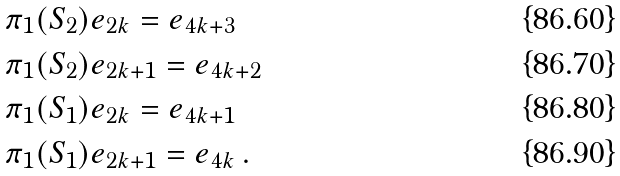Convert formula to latex. <formula><loc_0><loc_0><loc_500><loc_500>& \pi _ { 1 } ( S _ { 2 } ) e _ { 2 k } = e _ { 4 k + 3 } \\ & \pi _ { 1 } ( S _ { 2 } ) e _ { 2 k + 1 } = e _ { 4 k + 2 } \\ & \pi _ { 1 } ( S _ { 1 } ) e _ { 2 k } = e _ { 4 k + 1 } \\ & \pi _ { 1 } ( S _ { 1 } ) e _ { 2 k + 1 } = e _ { 4 k } \, .</formula> 